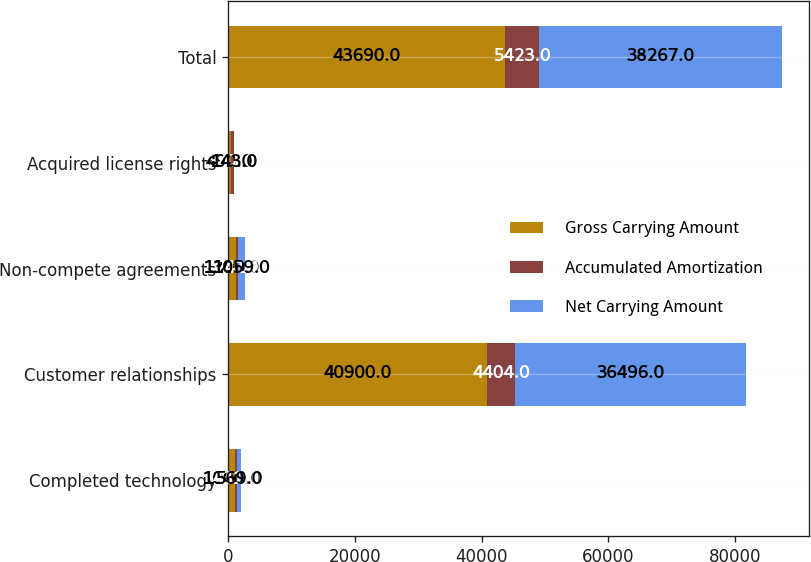<chart> <loc_0><loc_0><loc_500><loc_500><stacked_bar_chart><ecel><fcel>Completed technology<fcel>Customer relationships<fcel>Non-compete agreements<fcel>Acquired license rights<fcel>Total<nl><fcel>Gross Carrying Amount<fcel>1000<fcel>40900<fcel>1300<fcel>490<fcel>43690<nl><fcel>Accumulated Amortization<fcel>431<fcel>4404<fcel>241<fcel>347<fcel>5423<nl><fcel>Net Carrying Amount<fcel>569<fcel>36496<fcel>1059<fcel>143<fcel>38267<nl></chart> 